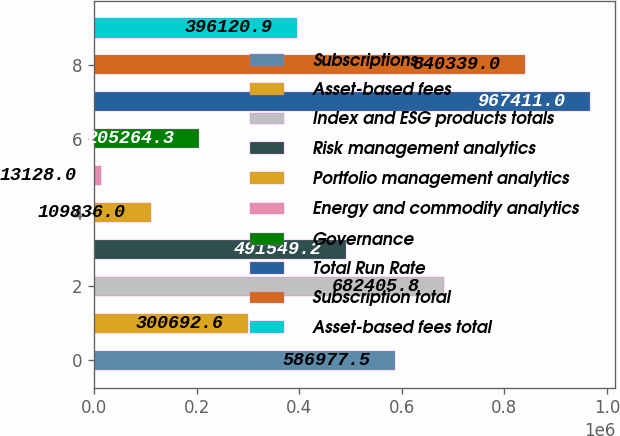<chart> <loc_0><loc_0><loc_500><loc_500><bar_chart><fcel>Subscriptions<fcel>Asset-based fees<fcel>Index and ESG products totals<fcel>Risk management analytics<fcel>Portfolio management analytics<fcel>Energy and commodity analytics<fcel>Governance<fcel>Total Run Rate<fcel>Subscription total<fcel>Asset-based fees total<nl><fcel>586978<fcel>300693<fcel>682406<fcel>491549<fcel>109836<fcel>13128<fcel>205264<fcel>967411<fcel>840339<fcel>396121<nl></chart> 